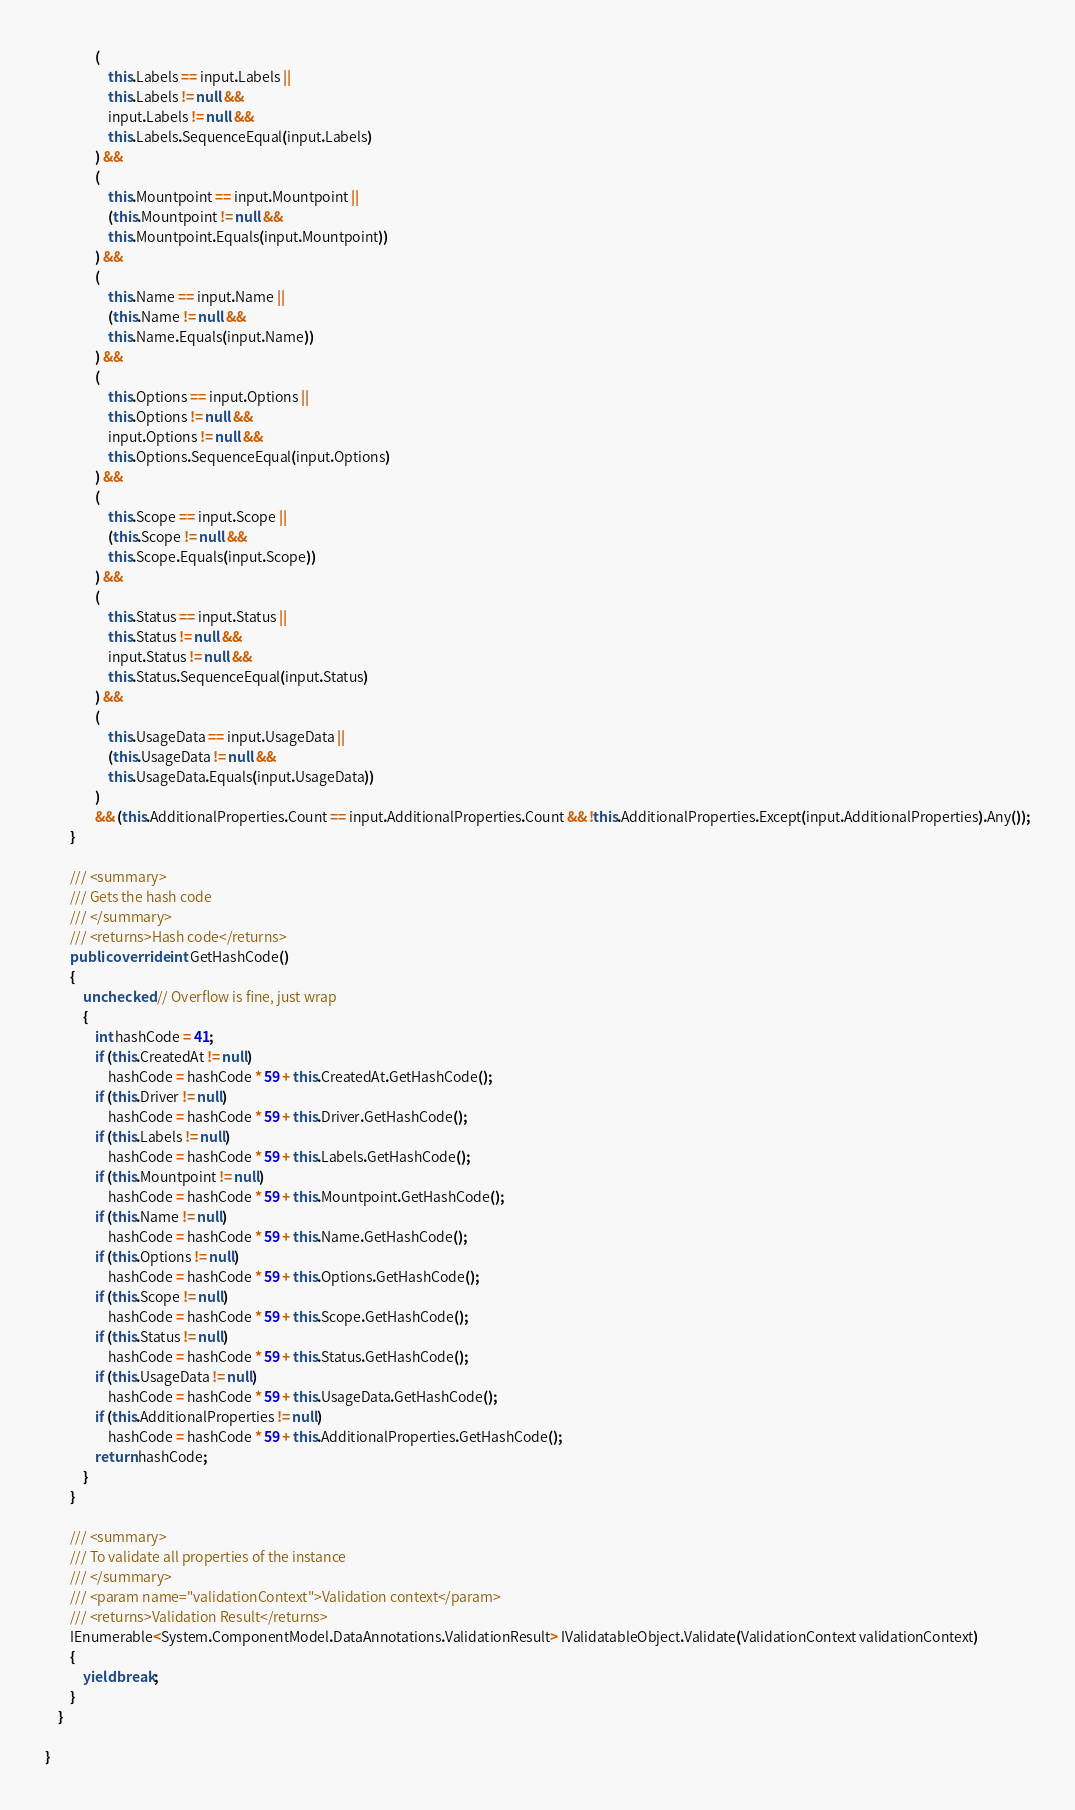<code> <loc_0><loc_0><loc_500><loc_500><_C#_>                (
                    this.Labels == input.Labels ||
                    this.Labels != null &&
                    input.Labels != null &&
                    this.Labels.SequenceEqual(input.Labels)
                ) && 
                (
                    this.Mountpoint == input.Mountpoint ||
                    (this.Mountpoint != null &&
                    this.Mountpoint.Equals(input.Mountpoint))
                ) && 
                (
                    this.Name == input.Name ||
                    (this.Name != null &&
                    this.Name.Equals(input.Name))
                ) && 
                (
                    this.Options == input.Options ||
                    this.Options != null &&
                    input.Options != null &&
                    this.Options.SequenceEqual(input.Options)
                ) && 
                (
                    this.Scope == input.Scope ||
                    (this.Scope != null &&
                    this.Scope.Equals(input.Scope))
                ) && 
                (
                    this.Status == input.Status ||
                    this.Status != null &&
                    input.Status != null &&
                    this.Status.SequenceEqual(input.Status)
                ) && 
                (
                    this.UsageData == input.UsageData ||
                    (this.UsageData != null &&
                    this.UsageData.Equals(input.UsageData))
                )
                && (this.AdditionalProperties.Count == input.AdditionalProperties.Count && !this.AdditionalProperties.Except(input.AdditionalProperties).Any());
        }

        /// <summary>
        /// Gets the hash code
        /// </summary>
        /// <returns>Hash code</returns>
        public override int GetHashCode()
        {
            unchecked // Overflow is fine, just wrap
            {
                int hashCode = 41;
                if (this.CreatedAt != null)
                    hashCode = hashCode * 59 + this.CreatedAt.GetHashCode();
                if (this.Driver != null)
                    hashCode = hashCode * 59 + this.Driver.GetHashCode();
                if (this.Labels != null)
                    hashCode = hashCode * 59 + this.Labels.GetHashCode();
                if (this.Mountpoint != null)
                    hashCode = hashCode * 59 + this.Mountpoint.GetHashCode();
                if (this.Name != null)
                    hashCode = hashCode * 59 + this.Name.GetHashCode();
                if (this.Options != null)
                    hashCode = hashCode * 59 + this.Options.GetHashCode();
                if (this.Scope != null)
                    hashCode = hashCode * 59 + this.Scope.GetHashCode();
                if (this.Status != null)
                    hashCode = hashCode * 59 + this.Status.GetHashCode();
                if (this.UsageData != null)
                    hashCode = hashCode * 59 + this.UsageData.GetHashCode();
                if (this.AdditionalProperties != null)
                    hashCode = hashCode * 59 + this.AdditionalProperties.GetHashCode();
                return hashCode;
            }
        }

        /// <summary>
        /// To validate all properties of the instance
        /// </summary>
        /// <param name="validationContext">Validation context</param>
        /// <returns>Validation Result</returns>
        IEnumerable<System.ComponentModel.DataAnnotations.ValidationResult> IValidatableObject.Validate(ValidationContext validationContext)
        {
            yield break;
        }
    }

}
</code> 